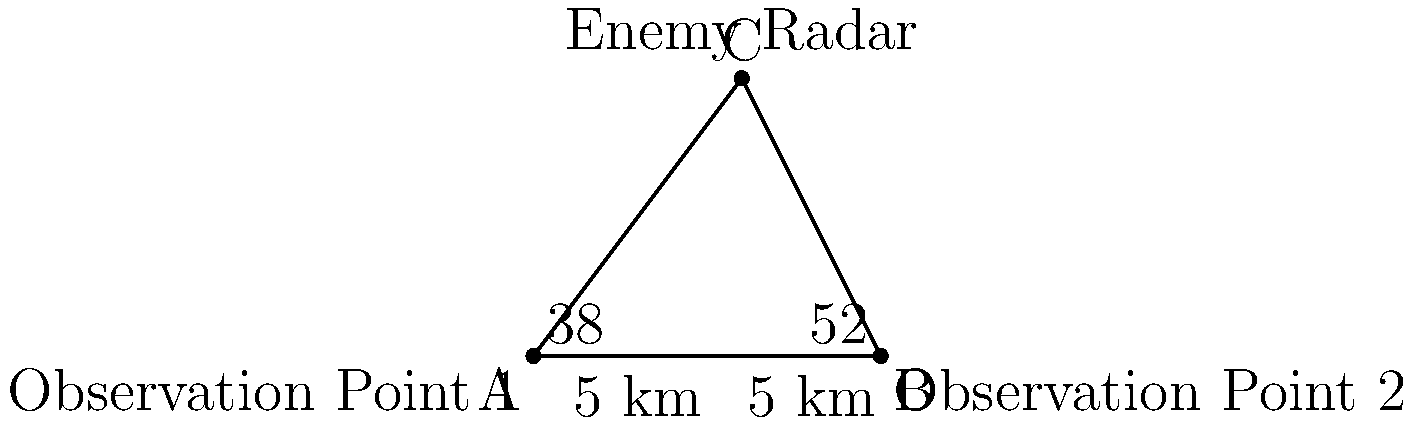Two observation points are set up 10 km apart to triangulate the position of an enemy radar installation. From Observation Point 1, the angle to the radar is measured as $38°$ from the line connecting the two observation points. From Observation Point 2, the angle is measured as $52°$. Calculate the distance from Observation Point 1 to the enemy radar installation. Let's approach this step-by-step using the law of sines:

1) Let's denote the distance from Observation Point 1 to the radar as $x$ km.

2) In the triangle formed by the two observation points and the radar:
   - We know the distance between observation points is 10 km.
   - The angle at Observation Point 1 is $38°$.
   - The angle at Observation Point 2 is $52°$.

3) The third angle in the triangle is: $180° - (38° + 52°) = 90°$

4) Now we can apply the law of sines:
   
   $$\frac{x}{\sin 52°} = \frac{10}{\sin 90°}$$

5) Simplify, knowing that $\sin 90° = 1$:
   
   $$\frac{x}{\sin 52°} = 10$$

6) Solve for $x$:
   
   $$x = 10 \sin 52°$$

7) Calculate:
   
   $$x \approx 10 * 0.7880 \approx 7.88 \text{ km}$$

Thus, the distance from Observation Point 1 to the enemy radar installation is approximately 7.88 km.
Answer: 7.88 km 